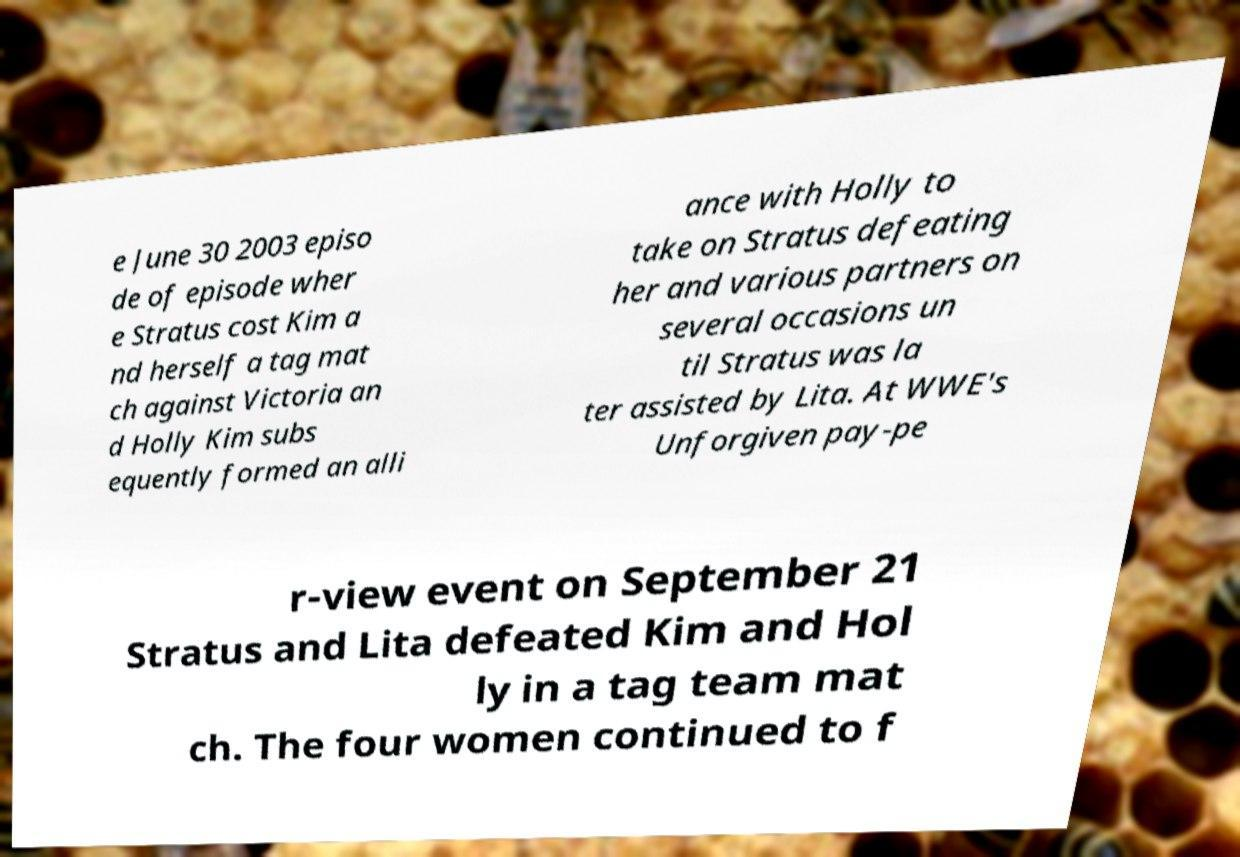For documentation purposes, I need the text within this image transcribed. Could you provide that? e June 30 2003 episo de of episode wher e Stratus cost Kim a nd herself a tag mat ch against Victoria an d Holly Kim subs equently formed an alli ance with Holly to take on Stratus defeating her and various partners on several occasions un til Stratus was la ter assisted by Lita. At WWE's Unforgiven pay-pe r-view event on September 21 Stratus and Lita defeated Kim and Hol ly in a tag team mat ch. The four women continued to f 